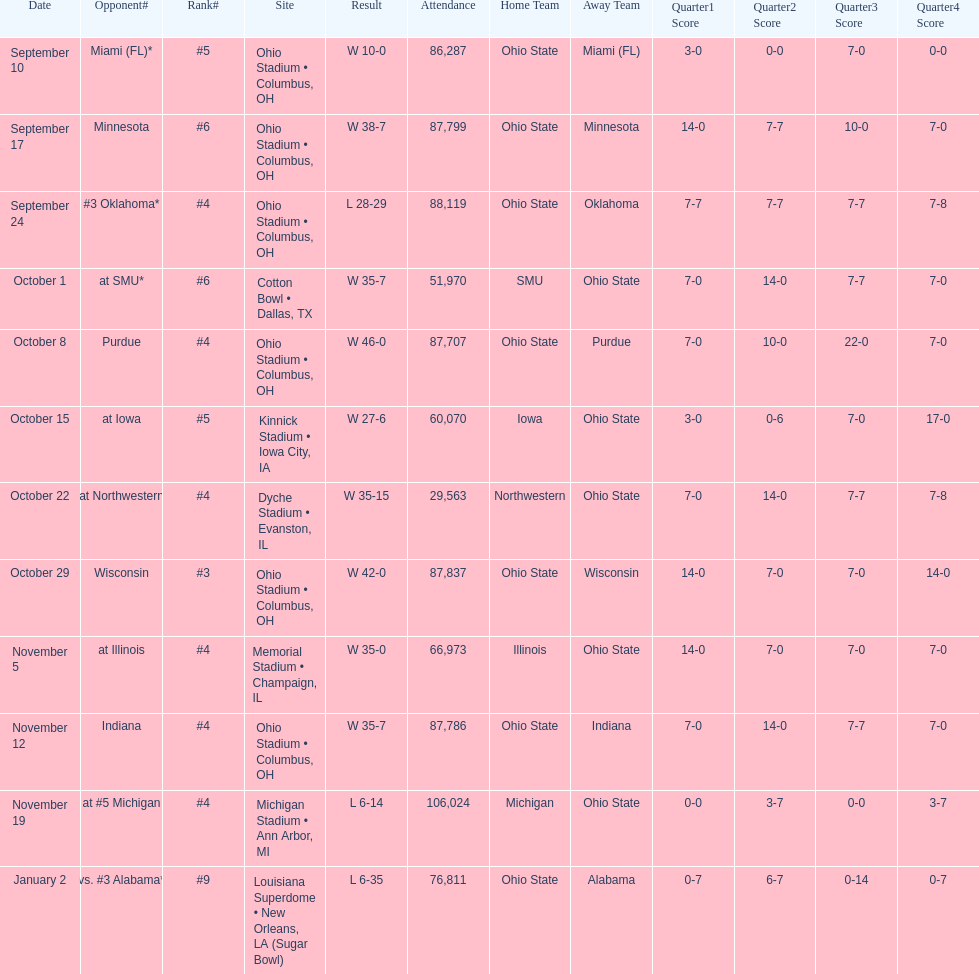How many dates are displayed on the diagram? 12. 